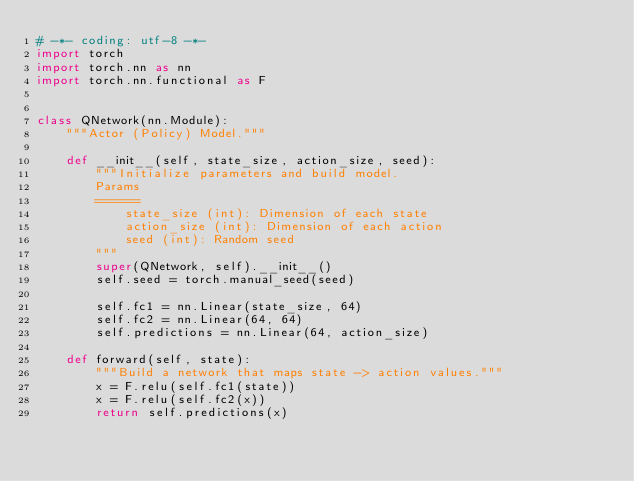<code> <loc_0><loc_0><loc_500><loc_500><_Python_># -*- coding: utf-8 -*-
import torch
import torch.nn as nn
import torch.nn.functional as F


class QNetwork(nn.Module):
    """Actor (Policy) Model."""

    def __init__(self, state_size, action_size, seed):
        """Initialize parameters and build model.
        Params
        ======
            state_size (int): Dimension of each state
            action_size (int): Dimension of each action
            seed (int): Random seed
        """
        super(QNetwork, self).__init__()
        self.seed = torch.manual_seed(seed)

        self.fc1 = nn.Linear(state_size, 64)
        self.fc2 = nn.Linear(64, 64)
        self.predictions = nn.Linear(64, action_size)

    def forward(self, state):
        """Build a network that maps state -> action values."""
        x = F.relu(self.fc1(state))
        x = F.relu(self.fc2(x))
        return self.predictions(x)
</code> 